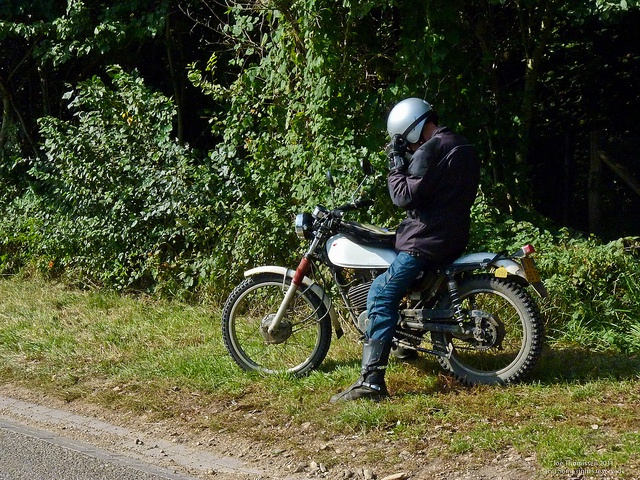Describe the objects in this image and their specific colors. I can see motorcycle in black, gray, darkgreen, and olive tones and people in black, gray, and darkgray tones in this image. 